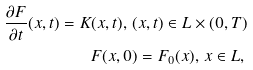Convert formula to latex. <formula><loc_0><loc_0><loc_500><loc_500>& & \frac { \partial F } { \partial t } ( x , t ) = K ( x , t ) , \, ( x , t ) \in L \times ( 0 , T ) \\ & & F ( x , 0 ) = F _ { 0 } ( x ) , \, x \in L , \,</formula> 